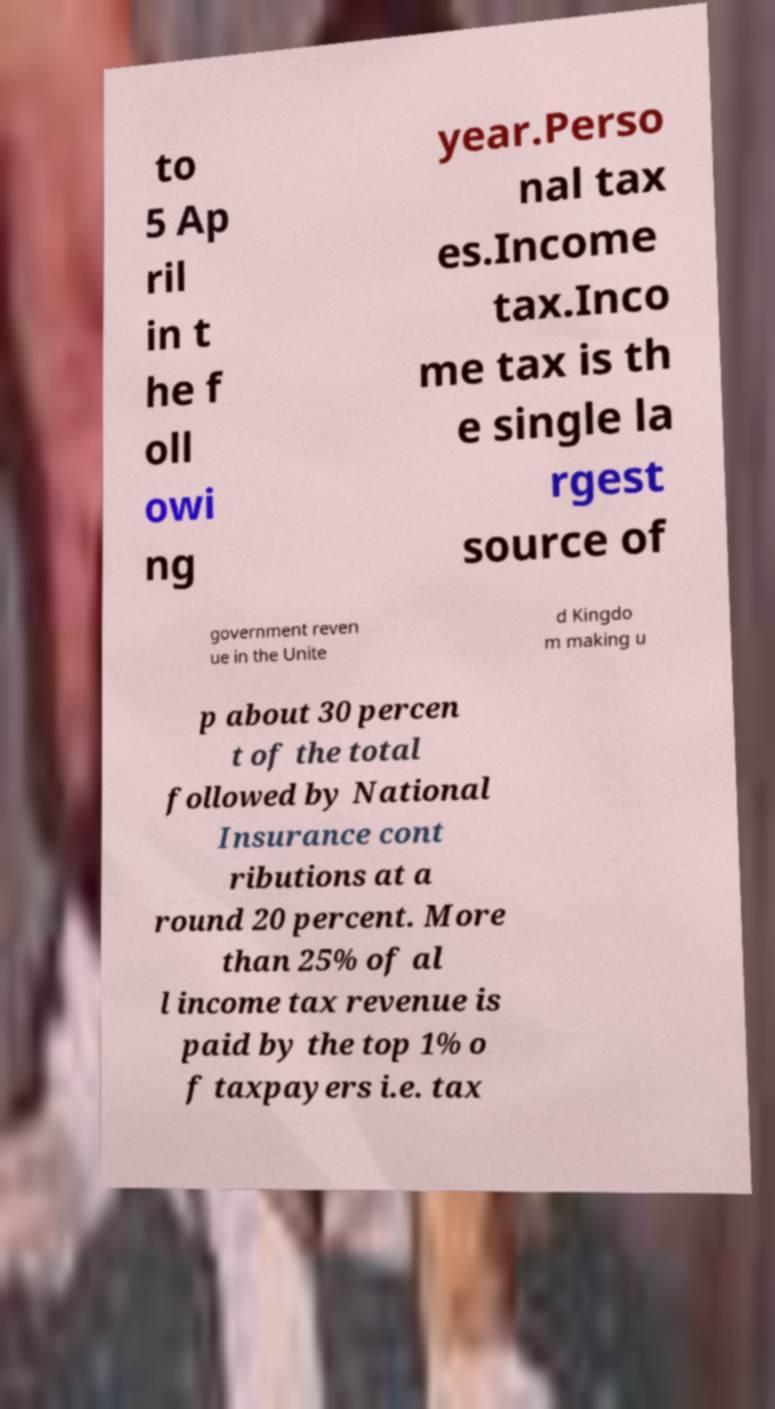Could you extract and type out the text from this image? to 5 Ap ril in t he f oll owi ng year.Perso nal tax es.Income tax.Inco me tax is th e single la rgest source of government reven ue in the Unite d Kingdo m making u p about 30 percen t of the total followed by National Insurance cont ributions at a round 20 percent. More than 25% of al l income tax revenue is paid by the top 1% o f taxpayers i.e. tax 